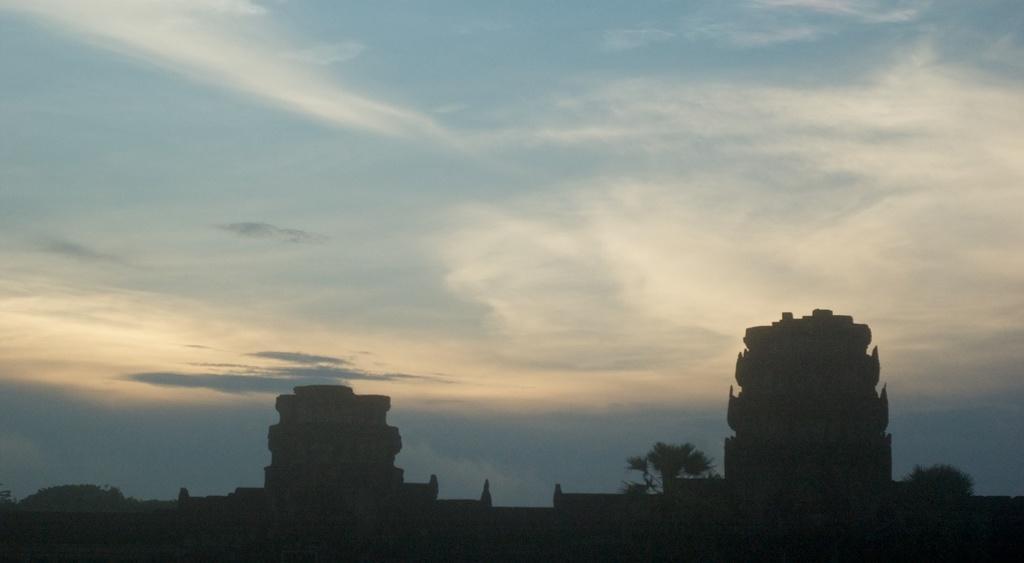How would you summarize this image in a sentence or two? In this image we can see few buildings. There are few trees in the image. We can see few clouds in the sky. 